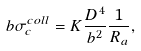<formula> <loc_0><loc_0><loc_500><loc_500>b \sigma _ { c } ^ { c o l l } = K \frac { D ^ { 4 } } { b ^ { 2 } } \frac { 1 } { R _ { a } } ,</formula> 